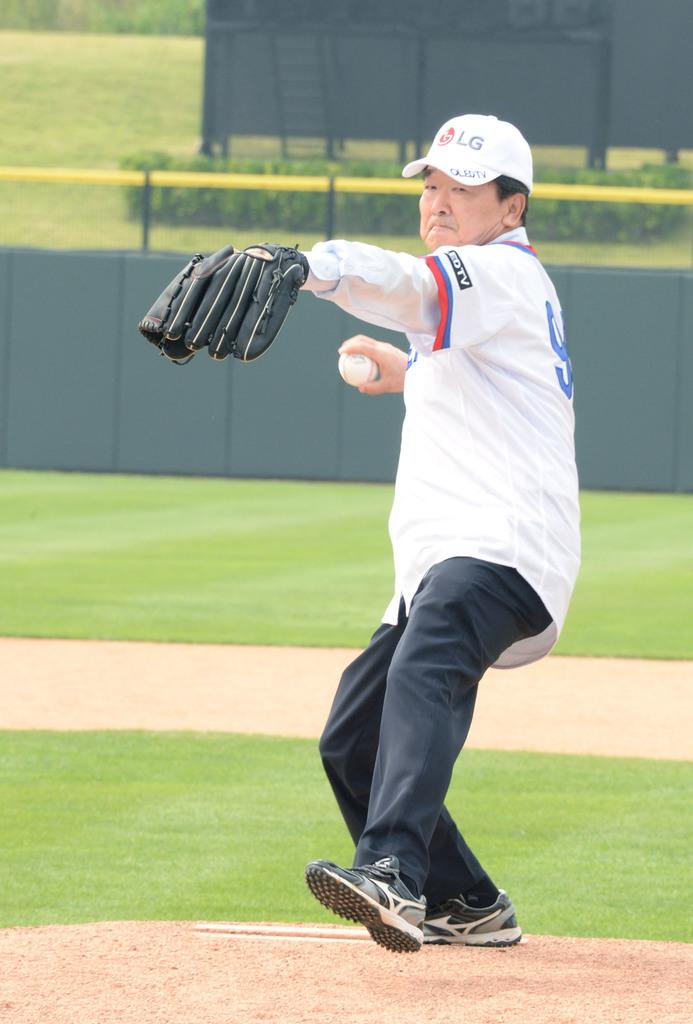Provide a one-sentence caption for the provided image. A man throwing a baseball in a LEDTV hat and jersey. 